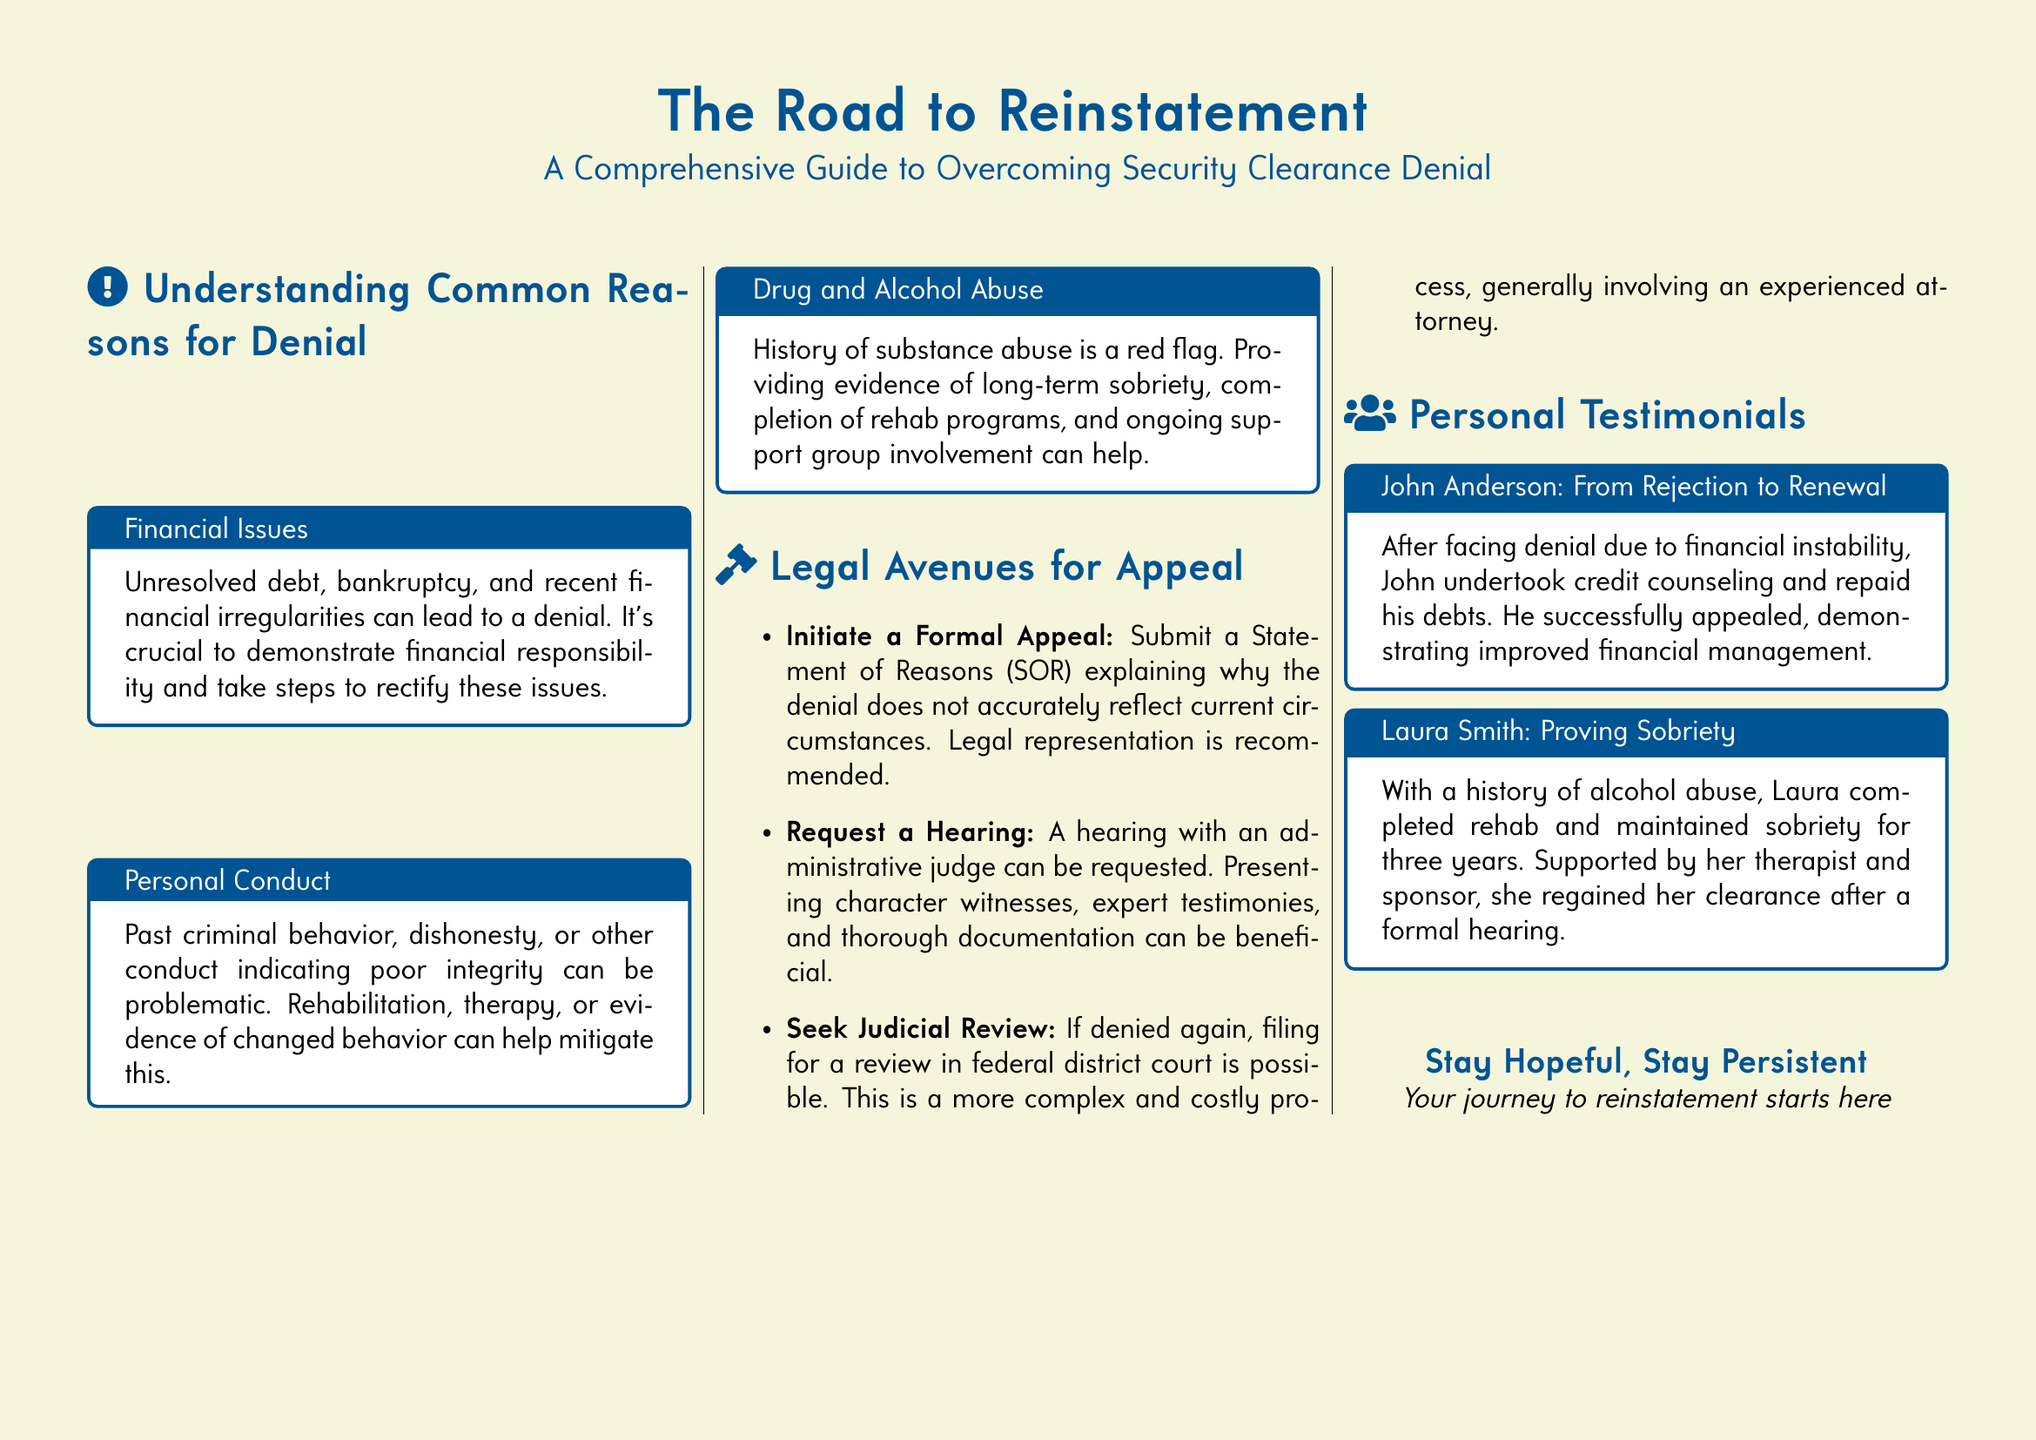What is the title of the guide? The title appears prominently at the top of the document.
Answer: The Road to Reinstatement What are the main topics covered in the document? The document includes sections on reasons for denial, legal avenues for appeal, and personal testimonials.
Answer: Reasons for denial, legal avenues for appeal, personal testimonials Who is featured in the testimonial regarding financial issues? The testimonial section names individuals who overcame security clearance denial.
Answer: John Anderson What should be included in a Statement of Reasons for appeal? The document explains the content required for a successful appeal.
Answer: Explanation of why the denial does not accurately reflect current circumstances How many years of sobriety did Laura Smith maintain? The document provides a timeline related to her sobriety during the appeal process.
Answer: Three years What color is the document's background? The overall aesthetic of the document is indicated by its background color.
Answer: Beige What type of support is suggested for applicants with a history of substance abuse? This information is relevant to mitigating concerns about past behavior during the appeals process.
Answer: Evidence of long-term sobriety, completion of rehab programs, and ongoing support group involvement What is the recommended action if a formal appeal is denied? This detail explains the next steps available to those facing continued denial.
Answer: Seek Judicial Review 